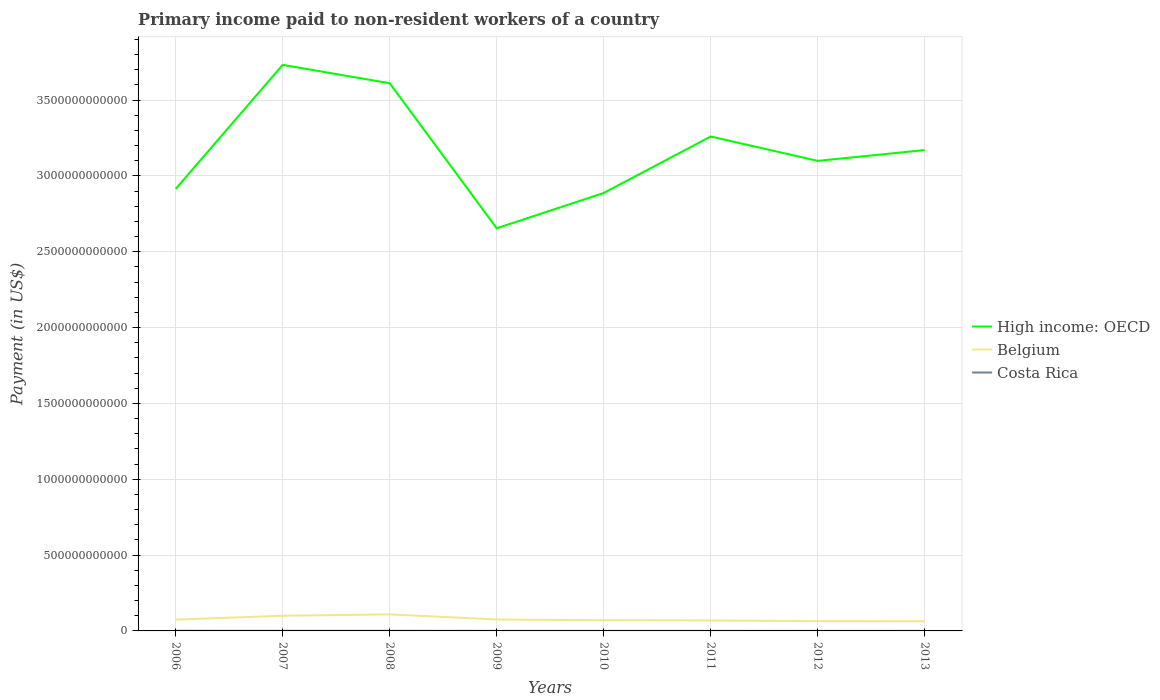How many different coloured lines are there?
Ensure brevity in your answer.  3. Does the line corresponding to High income: OECD intersect with the line corresponding to Belgium?
Your answer should be very brief. No. Across all years, what is the maximum amount paid to workers in Belgium?
Make the answer very short. 6.36e+1. In which year was the amount paid to workers in Belgium maximum?
Provide a succinct answer. 2013. What is the total amount paid to workers in Belgium in the graph?
Make the answer very short. 5.05e+09. What is the difference between the highest and the second highest amount paid to workers in Costa Rica?
Provide a short and direct response. 9.58e+08. What is the difference between the highest and the lowest amount paid to workers in High income: OECD?
Your answer should be very brief. 4. Is the amount paid to workers in High income: OECD strictly greater than the amount paid to workers in Belgium over the years?
Make the answer very short. No. What is the difference between two consecutive major ticks on the Y-axis?
Make the answer very short. 5.00e+11. Does the graph contain any zero values?
Keep it short and to the point. No. Does the graph contain grids?
Ensure brevity in your answer.  Yes. Where does the legend appear in the graph?
Offer a very short reply. Center right. How many legend labels are there?
Offer a terse response. 3. What is the title of the graph?
Make the answer very short. Primary income paid to non-resident workers of a country. Does "Moldova" appear as one of the legend labels in the graph?
Offer a very short reply. No. What is the label or title of the Y-axis?
Offer a terse response. Payment (in US$). What is the Payment (in US$) of High income: OECD in 2006?
Provide a succinct answer. 2.91e+12. What is the Payment (in US$) in Belgium in 2006?
Your answer should be very brief. 7.43e+1. What is the Payment (in US$) in Costa Rica in 2006?
Your response must be concise. 1.14e+09. What is the Payment (in US$) of High income: OECD in 2007?
Ensure brevity in your answer.  3.73e+12. What is the Payment (in US$) of Belgium in 2007?
Your answer should be compact. 1.00e+11. What is the Payment (in US$) of Costa Rica in 2007?
Keep it short and to the point. 7.08e+08. What is the Payment (in US$) of High income: OECD in 2008?
Provide a short and direct response. 3.61e+12. What is the Payment (in US$) of Belgium in 2008?
Offer a very short reply. 1.09e+11. What is the Payment (in US$) in Costa Rica in 2008?
Make the answer very short. 6.97e+08. What is the Payment (in US$) in High income: OECD in 2009?
Offer a very short reply. 2.66e+12. What is the Payment (in US$) of Belgium in 2009?
Your response must be concise. 7.54e+1. What is the Payment (in US$) in Costa Rica in 2009?
Your answer should be very brief. 1.96e+08. What is the Payment (in US$) in High income: OECD in 2010?
Give a very brief answer. 2.89e+12. What is the Payment (in US$) in Belgium in 2010?
Offer a terse response. 7.06e+1. What is the Payment (in US$) in Costa Rica in 2010?
Provide a short and direct response. 1.77e+08. What is the Payment (in US$) in High income: OECD in 2011?
Make the answer very short. 3.26e+12. What is the Payment (in US$) of Belgium in 2011?
Keep it short and to the point. 6.92e+1. What is the Payment (in US$) in Costa Rica in 2011?
Ensure brevity in your answer.  2.45e+08. What is the Payment (in US$) in High income: OECD in 2012?
Provide a succinct answer. 3.10e+12. What is the Payment (in US$) of Belgium in 2012?
Keep it short and to the point. 6.41e+1. What is the Payment (in US$) of Costa Rica in 2012?
Make the answer very short. 2.92e+08. What is the Payment (in US$) of High income: OECD in 2013?
Provide a short and direct response. 3.17e+12. What is the Payment (in US$) in Belgium in 2013?
Your response must be concise. 6.36e+1. What is the Payment (in US$) of Costa Rica in 2013?
Provide a short and direct response. 2.24e+08. Across all years, what is the maximum Payment (in US$) in High income: OECD?
Keep it short and to the point. 3.73e+12. Across all years, what is the maximum Payment (in US$) in Belgium?
Your answer should be very brief. 1.09e+11. Across all years, what is the maximum Payment (in US$) in Costa Rica?
Your answer should be very brief. 1.14e+09. Across all years, what is the minimum Payment (in US$) of High income: OECD?
Offer a very short reply. 2.66e+12. Across all years, what is the minimum Payment (in US$) in Belgium?
Offer a very short reply. 6.36e+1. Across all years, what is the minimum Payment (in US$) in Costa Rica?
Ensure brevity in your answer.  1.77e+08. What is the total Payment (in US$) in High income: OECD in the graph?
Your answer should be very brief. 2.53e+13. What is the total Payment (in US$) of Belgium in the graph?
Your response must be concise. 6.26e+11. What is the total Payment (in US$) of Costa Rica in the graph?
Make the answer very short. 3.67e+09. What is the difference between the Payment (in US$) in High income: OECD in 2006 and that in 2007?
Make the answer very short. -8.18e+11. What is the difference between the Payment (in US$) of Belgium in 2006 and that in 2007?
Your response must be concise. -2.58e+1. What is the difference between the Payment (in US$) in Costa Rica in 2006 and that in 2007?
Keep it short and to the point. 4.27e+08. What is the difference between the Payment (in US$) of High income: OECD in 2006 and that in 2008?
Provide a succinct answer. -6.97e+11. What is the difference between the Payment (in US$) of Belgium in 2006 and that in 2008?
Make the answer very short. -3.48e+1. What is the difference between the Payment (in US$) of Costa Rica in 2006 and that in 2008?
Your answer should be compact. 4.38e+08. What is the difference between the Payment (in US$) of High income: OECD in 2006 and that in 2009?
Your answer should be compact. 2.59e+11. What is the difference between the Payment (in US$) in Belgium in 2006 and that in 2009?
Provide a succinct answer. -1.16e+09. What is the difference between the Payment (in US$) in Costa Rica in 2006 and that in 2009?
Keep it short and to the point. 9.39e+08. What is the difference between the Payment (in US$) in High income: OECD in 2006 and that in 2010?
Provide a short and direct response. 2.69e+1. What is the difference between the Payment (in US$) of Belgium in 2006 and that in 2010?
Offer a very short reply. 3.67e+09. What is the difference between the Payment (in US$) of Costa Rica in 2006 and that in 2010?
Ensure brevity in your answer.  9.58e+08. What is the difference between the Payment (in US$) of High income: OECD in 2006 and that in 2011?
Ensure brevity in your answer.  -3.45e+11. What is the difference between the Payment (in US$) of Belgium in 2006 and that in 2011?
Keep it short and to the point. 5.10e+09. What is the difference between the Payment (in US$) of Costa Rica in 2006 and that in 2011?
Offer a terse response. 8.90e+08. What is the difference between the Payment (in US$) in High income: OECD in 2006 and that in 2012?
Ensure brevity in your answer.  -1.85e+11. What is the difference between the Payment (in US$) in Belgium in 2006 and that in 2012?
Your answer should be very brief. 1.02e+1. What is the difference between the Payment (in US$) in Costa Rica in 2006 and that in 2012?
Keep it short and to the point. 8.43e+08. What is the difference between the Payment (in US$) of High income: OECD in 2006 and that in 2013?
Your response must be concise. -2.56e+11. What is the difference between the Payment (in US$) in Belgium in 2006 and that in 2013?
Offer a terse response. 1.07e+1. What is the difference between the Payment (in US$) in Costa Rica in 2006 and that in 2013?
Offer a very short reply. 9.11e+08. What is the difference between the Payment (in US$) of High income: OECD in 2007 and that in 2008?
Provide a succinct answer. 1.21e+11. What is the difference between the Payment (in US$) in Belgium in 2007 and that in 2008?
Your response must be concise. -8.97e+09. What is the difference between the Payment (in US$) of Costa Rica in 2007 and that in 2008?
Offer a terse response. 1.08e+07. What is the difference between the Payment (in US$) in High income: OECD in 2007 and that in 2009?
Make the answer very short. 1.08e+12. What is the difference between the Payment (in US$) in Belgium in 2007 and that in 2009?
Give a very brief answer. 2.47e+1. What is the difference between the Payment (in US$) of Costa Rica in 2007 and that in 2009?
Keep it short and to the point. 5.11e+08. What is the difference between the Payment (in US$) in High income: OECD in 2007 and that in 2010?
Your response must be concise. 8.45e+11. What is the difference between the Payment (in US$) in Belgium in 2007 and that in 2010?
Give a very brief answer. 2.95e+1. What is the difference between the Payment (in US$) of Costa Rica in 2007 and that in 2010?
Make the answer very short. 5.31e+08. What is the difference between the Payment (in US$) in High income: OECD in 2007 and that in 2011?
Offer a terse response. 4.72e+11. What is the difference between the Payment (in US$) in Belgium in 2007 and that in 2011?
Make the answer very short. 3.09e+1. What is the difference between the Payment (in US$) in Costa Rica in 2007 and that in 2011?
Ensure brevity in your answer.  4.63e+08. What is the difference between the Payment (in US$) of High income: OECD in 2007 and that in 2012?
Provide a succinct answer. 6.33e+11. What is the difference between the Payment (in US$) in Belgium in 2007 and that in 2012?
Your answer should be very brief. 3.60e+1. What is the difference between the Payment (in US$) of Costa Rica in 2007 and that in 2012?
Ensure brevity in your answer.  4.16e+08. What is the difference between the Payment (in US$) of High income: OECD in 2007 and that in 2013?
Ensure brevity in your answer.  5.62e+11. What is the difference between the Payment (in US$) in Belgium in 2007 and that in 2013?
Offer a very short reply. 3.65e+1. What is the difference between the Payment (in US$) of Costa Rica in 2007 and that in 2013?
Keep it short and to the point. 4.83e+08. What is the difference between the Payment (in US$) in High income: OECD in 2008 and that in 2009?
Offer a very short reply. 9.56e+11. What is the difference between the Payment (in US$) in Belgium in 2008 and that in 2009?
Provide a succinct answer. 3.36e+1. What is the difference between the Payment (in US$) in Costa Rica in 2008 and that in 2009?
Give a very brief answer. 5.00e+08. What is the difference between the Payment (in US$) in High income: OECD in 2008 and that in 2010?
Make the answer very short. 7.24e+11. What is the difference between the Payment (in US$) of Belgium in 2008 and that in 2010?
Provide a succinct answer. 3.84e+1. What is the difference between the Payment (in US$) of Costa Rica in 2008 and that in 2010?
Ensure brevity in your answer.  5.20e+08. What is the difference between the Payment (in US$) of High income: OECD in 2008 and that in 2011?
Ensure brevity in your answer.  3.51e+11. What is the difference between the Payment (in US$) of Belgium in 2008 and that in 2011?
Provide a short and direct response. 3.99e+1. What is the difference between the Payment (in US$) in Costa Rica in 2008 and that in 2011?
Your answer should be compact. 4.52e+08. What is the difference between the Payment (in US$) of High income: OECD in 2008 and that in 2012?
Your response must be concise. 5.12e+11. What is the difference between the Payment (in US$) in Belgium in 2008 and that in 2012?
Ensure brevity in your answer.  4.49e+1. What is the difference between the Payment (in US$) of Costa Rica in 2008 and that in 2012?
Your answer should be very brief. 4.05e+08. What is the difference between the Payment (in US$) of High income: OECD in 2008 and that in 2013?
Offer a terse response. 4.41e+11. What is the difference between the Payment (in US$) in Belgium in 2008 and that in 2013?
Provide a short and direct response. 4.55e+1. What is the difference between the Payment (in US$) of Costa Rica in 2008 and that in 2013?
Offer a terse response. 4.72e+08. What is the difference between the Payment (in US$) in High income: OECD in 2009 and that in 2010?
Give a very brief answer. -2.33e+11. What is the difference between the Payment (in US$) of Belgium in 2009 and that in 2010?
Your answer should be compact. 4.83e+09. What is the difference between the Payment (in US$) of Costa Rica in 2009 and that in 2010?
Ensure brevity in your answer.  1.96e+07. What is the difference between the Payment (in US$) in High income: OECD in 2009 and that in 2011?
Your answer should be very brief. -6.05e+11. What is the difference between the Payment (in US$) in Belgium in 2009 and that in 2011?
Your response must be concise. 6.25e+09. What is the difference between the Payment (in US$) of Costa Rica in 2009 and that in 2011?
Provide a short and direct response. -4.87e+07. What is the difference between the Payment (in US$) in High income: OECD in 2009 and that in 2012?
Offer a very short reply. -4.44e+11. What is the difference between the Payment (in US$) in Belgium in 2009 and that in 2012?
Provide a short and direct response. 1.13e+1. What is the difference between the Payment (in US$) in Costa Rica in 2009 and that in 2012?
Offer a very short reply. -9.52e+07. What is the difference between the Payment (in US$) of High income: OECD in 2009 and that in 2013?
Keep it short and to the point. -5.16e+11. What is the difference between the Payment (in US$) in Belgium in 2009 and that in 2013?
Ensure brevity in your answer.  1.18e+1. What is the difference between the Payment (in US$) in Costa Rica in 2009 and that in 2013?
Offer a very short reply. -2.80e+07. What is the difference between the Payment (in US$) of High income: OECD in 2010 and that in 2011?
Provide a short and direct response. -3.72e+11. What is the difference between the Payment (in US$) in Belgium in 2010 and that in 2011?
Keep it short and to the point. 1.43e+09. What is the difference between the Payment (in US$) of Costa Rica in 2010 and that in 2011?
Ensure brevity in your answer.  -6.83e+07. What is the difference between the Payment (in US$) of High income: OECD in 2010 and that in 2012?
Offer a terse response. -2.12e+11. What is the difference between the Payment (in US$) in Belgium in 2010 and that in 2012?
Provide a short and direct response. 6.48e+09. What is the difference between the Payment (in US$) in Costa Rica in 2010 and that in 2012?
Your answer should be compact. -1.15e+08. What is the difference between the Payment (in US$) of High income: OECD in 2010 and that in 2013?
Provide a succinct answer. -2.83e+11. What is the difference between the Payment (in US$) of Belgium in 2010 and that in 2013?
Give a very brief answer. 7.02e+09. What is the difference between the Payment (in US$) in Costa Rica in 2010 and that in 2013?
Provide a short and direct response. -4.76e+07. What is the difference between the Payment (in US$) in High income: OECD in 2011 and that in 2012?
Provide a short and direct response. 1.61e+11. What is the difference between the Payment (in US$) in Belgium in 2011 and that in 2012?
Offer a very short reply. 5.05e+09. What is the difference between the Payment (in US$) in Costa Rica in 2011 and that in 2012?
Give a very brief answer. -4.65e+07. What is the difference between the Payment (in US$) in High income: OECD in 2011 and that in 2013?
Provide a short and direct response. 8.92e+1. What is the difference between the Payment (in US$) of Belgium in 2011 and that in 2013?
Your answer should be very brief. 5.59e+09. What is the difference between the Payment (in US$) in Costa Rica in 2011 and that in 2013?
Provide a short and direct response. 2.07e+07. What is the difference between the Payment (in US$) of High income: OECD in 2012 and that in 2013?
Provide a short and direct response. -7.13e+1. What is the difference between the Payment (in US$) of Belgium in 2012 and that in 2013?
Offer a very short reply. 5.38e+08. What is the difference between the Payment (in US$) of Costa Rica in 2012 and that in 2013?
Your response must be concise. 6.72e+07. What is the difference between the Payment (in US$) in High income: OECD in 2006 and the Payment (in US$) in Belgium in 2007?
Keep it short and to the point. 2.81e+12. What is the difference between the Payment (in US$) of High income: OECD in 2006 and the Payment (in US$) of Costa Rica in 2007?
Your answer should be very brief. 2.91e+12. What is the difference between the Payment (in US$) of Belgium in 2006 and the Payment (in US$) of Costa Rica in 2007?
Keep it short and to the point. 7.36e+1. What is the difference between the Payment (in US$) of High income: OECD in 2006 and the Payment (in US$) of Belgium in 2008?
Provide a short and direct response. 2.81e+12. What is the difference between the Payment (in US$) in High income: OECD in 2006 and the Payment (in US$) in Costa Rica in 2008?
Your answer should be very brief. 2.91e+12. What is the difference between the Payment (in US$) in Belgium in 2006 and the Payment (in US$) in Costa Rica in 2008?
Offer a very short reply. 7.36e+1. What is the difference between the Payment (in US$) in High income: OECD in 2006 and the Payment (in US$) in Belgium in 2009?
Keep it short and to the point. 2.84e+12. What is the difference between the Payment (in US$) of High income: OECD in 2006 and the Payment (in US$) of Costa Rica in 2009?
Make the answer very short. 2.91e+12. What is the difference between the Payment (in US$) in Belgium in 2006 and the Payment (in US$) in Costa Rica in 2009?
Offer a very short reply. 7.41e+1. What is the difference between the Payment (in US$) of High income: OECD in 2006 and the Payment (in US$) of Belgium in 2010?
Provide a short and direct response. 2.84e+12. What is the difference between the Payment (in US$) in High income: OECD in 2006 and the Payment (in US$) in Costa Rica in 2010?
Make the answer very short. 2.91e+12. What is the difference between the Payment (in US$) of Belgium in 2006 and the Payment (in US$) of Costa Rica in 2010?
Offer a very short reply. 7.41e+1. What is the difference between the Payment (in US$) in High income: OECD in 2006 and the Payment (in US$) in Belgium in 2011?
Ensure brevity in your answer.  2.85e+12. What is the difference between the Payment (in US$) of High income: OECD in 2006 and the Payment (in US$) of Costa Rica in 2011?
Make the answer very short. 2.91e+12. What is the difference between the Payment (in US$) of Belgium in 2006 and the Payment (in US$) of Costa Rica in 2011?
Give a very brief answer. 7.40e+1. What is the difference between the Payment (in US$) of High income: OECD in 2006 and the Payment (in US$) of Belgium in 2012?
Ensure brevity in your answer.  2.85e+12. What is the difference between the Payment (in US$) in High income: OECD in 2006 and the Payment (in US$) in Costa Rica in 2012?
Provide a short and direct response. 2.91e+12. What is the difference between the Payment (in US$) in Belgium in 2006 and the Payment (in US$) in Costa Rica in 2012?
Offer a terse response. 7.40e+1. What is the difference between the Payment (in US$) in High income: OECD in 2006 and the Payment (in US$) in Belgium in 2013?
Offer a very short reply. 2.85e+12. What is the difference between the Payment (in US$) of High income: OECD in 2006 and the Payment (in US$) of Costa Rica in 2013?
Offer a terse response. 2.91e+12. What is the difference between the Payment (in US$) of Belgium in 2006 and the Payment (in US$) of Costa Rica in 2013?
Your answer should be compact. 7.41e+1. What is the difference between the Payment (in US$) of High income: OECD in 2007 and the Payment (in US$) of Belgium in 2008?
Ensure brevity in your answer.  3.62e+12. What is the difference between the Payment (in US$) of High income: OECD in 2007 and the Payment (in US$) of Costa Rica in 2008?
Make the answer very short. 3.73e+12. What is the difference between the Payment (in US$) of Belgium in 2007 and the Payment (in US$) of Costa Rica in 2008?
Your answer should be compact. 9.94e+1. What is the difference between the Payment (in US$) in High income: OECD in 2007 and the Payment (in US$) in Belgium in 2009?
Offer a very short reply. 3.66e+12. What is the difference between the Payment (in US$) in High income: OECD in 2007 and the Payment (in US$) in Costa Rica in 2009?
Keep it short and to the point. 3.73e+12. What is the difference between the Payment (in US$) in Belgium in 2007 and the Payment (in US$) in Costa Rica in 2009?
Your answer should be very brief. 9.99e+1. What is the difference between the Payment (in US$) in High income: OECD in 2007 and the Payment (in US$) in Belgium in 2010?
Offer a terse response. 3.66e+12. What is the difference between the Payment (in US$) of High income: OECD in 2007 and the Payment (in US$) of Costa Rica in 2010?
Keep it short and to the point. 3.73e+12. What is the difference between the Payment (in US$) in Belgium in 2007 and the Payment (in US$) in Costa Rica in 2010?
Provide a short and direct response. 9.99e+1. What is the difference between the Payment (in US$) in High income: OECD in 2007 and the Payment (in US$) in Belgium in 2011?
Offer a terse response. 3.66e+12. What is the difference between the Payment (in US$) in High income: OECD in 2007 and the Payment (in US$) in Costa Rica in 2011?
Your answer should be very brief. 3.73e+12. What is the difference between the Payment (in US$) of Belgium in 2007 and the Payment (in US$) of Costa Rica in 2011?
Provide a succinct answer. 9.98e+1. What is the difference between the Payment (in US$) in High income: OECD in 2007 and the Payment (in US$) in Belgium in 2012?
Make the answer very short. 3.67e+12. What is the difference between the Payment (in US$) in High income: OECD in 2007 and the Payment (in US$) in Costa Rica in 2012?
Your answer should be compact. 3.73e+12. What is the difference between the Payment (in US$) in Belgium in 2007 and the Payment (in US$) in Costa Rica in 2012?
Provide a succinct answer. 9.98e+1. What is the difference between the Payment (in US$) in High income: OECD in 2007 and the Payment (in US$) in Belgium in 2013?
Keep it short and to the point. 3.67e+12. What is the difference between the Payment (in US$) of High income: OECD in 2007 and the Payment (in US$) of Costa Rica in 2013?
Keep it short and to the point. 3.73e+12. What is the difference between the Payment (in US$) of Belgium in 2007 and the Payment (in US$) of Costa Rica in 2013?
Ensure brevity in your answer.  9.99e+1. What is the difference between the Payment (in US$) of High income: OECD in 2008 and the Payment (in US$) of Belgium in 2009?
Provide a short and direct response. 3.54e+12. What is the difference between the Payment (in US$) in High income: OECD in 2008 and the Payment (in US$) in Costa Rica in 2009?
Keep it short and to the point. 3.61e+12. What is the difference between the Payment (in US$) of Belgium in 2008 and the Payment (in US$) of Costa Rica in 2009?
Make the answer very short. 1.09e+11. What is the difference between the Payment (in US$) of High income: OECD in 2008 and the Payment (in US$) of Belgium in 2010?
Your response must be concise. 3.54e+12. What is the difference between the Payment (in US$) of High income: OECD in 2008 and the Payment (in US$) of Costa Rica in 2010?
Give a very brief answer. 3.61e+12. What is the difference between the Payment (in US$) in Belgium in 2008 and the Payment (in US$) in Costa Rica in 2010?
Provide a succinct answer. 1.09e+11. What is the difference between the Payment (in US$) of High income: OECD in 2008 and the Payment (in US$) of Belgium in 2011?
Offer a terse response. 3.54e+12. What is the difference between the Payment (in US$) of High income: OECD in 2008 and the Payment (in US$) of Costa Rica in 2011?
Provide a short and direct response. 3.61e+12. What is the difference between the Payment (in US$) of Belgium in 2008 and the Payment (in US$) of Costa Rica in 2011?
Make the answer very short. 1.09e+11. What is the difference between the Payment (in US$) in High income: OECD in 2008 and the Payment (in US$) in Belgium in 2012?
Your answer should be compact. 3.55e+12. What is the difference between the Payment (in US$) of High income: OECD in 2008 and the Payment (in US$) of Costa Rica in 2012?
Ensure brevity in your answer.  3.61e+12. What is the difference between the Payment (in US$) of Belgium in 2008 and the Payment (in US$) of Costa Rica in 2012?
Provide a succinct answer. 1.09e+11. What is the difference between the Payment (in US$) in High income: OECD in 2008 and the Payment (in US$) in Belgium in 2013?
Offer a terse response. 3.55e+12. What is the difference between the Payment (in US$) in High income: OECD in 2008 and the Payment (in US$) in Costa Rica in 2013?
Keep it short and to the point. 3.61e+12. What is the difference between the Payment (in US$) in Belgium in 2008 and the Payment (in US$) in Costa Rica in 2013?
Offer a terse response. 1.09e+11. What is the difference between the Payment (in US$) in High income: OECD in 2009 and the Payment (in US$) in Belgium in 2010?
Offer a terse response. 2.58e+12. What is the difference between the Payment (in US$) in High income: OECD in 2009 and the Payment (in US$) in Costa Rica in 2010?
Provide a short and direct response. 2.66e+12. What is the difference between the Payment (in US$) in Belgium in 2009 and the Payment (in US$) in Costa Rica in 2010?
Make the answer very short. 7.53e+1. What is the difference between the Payment (in US$) in High income: OECD in 2009 and the Payment (in US$) in Belgium in 2011?
Your answer should be compact. 2.59e+12. What is the difference between the Payment (in US$) of High income: OECD in 2009 and the Payment (in US$) of Costa Rica in 2011?
Make the answer very short. 2.65e+12. What is the difference between the Payment (in US$) in Belgium in 2009 and the Payment (in US$) in Costa Rica in 2011?
Provide a short and direct response. 7.52e+1. What is the difference between the Payment (in US$) in High income: OECD in 2009 and the Payment (in US$) in Belgium in 2012?
Provide a succinct answer. 2.59e+12. What is the difference between the Payment (in US$) of High income: OECD in 2009 and the Payment (in US$) of Costa Rica in 2012?
Your answer should be compact. 2.65e+12. What is the difference between the Payment (in US$) of Belgium in 2009 and the Payment (in US$) of Costa Rica in 2012?
Make the answer very short. 7.51e+1. What is the difference between the Payment (in US$) in High income: OECD in 2009 and the Payment (in US$) in Belgium in 2013?
Your answer should be compact. 2.59e+12. What is the difference between the Payment (in US$) in High income: OECD in 2009 and the Payment (in US$) in Costa Rica in 2013?
Provide a short and direct response. 2.65e+12. What is the difference between the Payment (in US$) in Belgium in 2009 and the Payment (in US$) in Costa Rica in 2013?
Your response must be concise. 7.52e+1. What is the difference between the Payment (in US$) of High income: OECD in 2010 and the Payment (in US$) of Belgium in 2011?
Provide a short and direct response. 2.82e+12. What is the difference between the Payment (in US$) in High income: OECD in 2010 and the Payment (in US$) in Costa Rica in 2011?
Provide a short and direct response. 2.89e+12. What is the difference between the Payment (in US$) of Belgium in 2010 and the Payment (in US$) of Costa Rica in 2011?
Make the answer very short. 7.04e+1. What is the difference between the Payment (in US$) in High income: OECD in 2010 and the Payment (in US$) in Belgium in 2012?
Provide a succinct answer. 2.82e+12. What is the difference between the Payment (in US$) in High income: OECD in 2010 and the Payment (in US$) in Costa Rica in 2012?
Make the answer very short. 2.89e+12. What is the difference between the Payment (in US$) of Belgium in 2010 and the Payment (in US$) of Costa Rica in 2012?
Offer a very short reply. 7.03e+1. What is the difference between the Payment (in US$) of High income: OECD in 2010 and the Payment (in US$) of Belgium in 2013?
Your answer should be very brief. 2.82e+12. What is the difference between the Payment (in US$) of High income: OECD in 2010 and the Payment (in US$) of Costa Rica in 2013?
Your answer should be compact. 2.89e+12. What is the difference between the Payment (in US$) in Belgium in 2010 and the Payment (in US$) in Costa Rica in 2013?
Provide a succinct answer. 7.04e+1. What is the difference between the Payment (in US$) in High income: OECD in 2011 and the Payment (in US$) in Belgium in 2012?
Provide a short and direct response. 3.20e+12. What is the difference between the Payment (in US$) in High income: OECD in 2011 and the Payment (in US$) in Costa Rica in 2012?
Your answer should be compact. 3.26e+12. What is the difference between the Payment (in US$) of Belgium in 2011 and the Payment (in US$) of Costa Rica in 2012?
Your answer should be very brief. 6.89e+1. What is the difference between the Payment (in US$) of High income: OECD in 2011 and the Payment (in US$) of Belgium in 2013?
Your answer should be very brief. 3.20e+12. What is the difference between the Payment (in US$) of High income: OECD in 2011 and the Payment (in US$) of Costa Rica in 2013?
Make the answer very short. 3.26e+12. What is the difference between the Payment (in US$) of Belgium in 2011 and the Payment (in US$) of Costa Rica in 2013?
Keep it short and to the point. 6.90e+1. What is the difference between the Payment (in US$) of High income: OECD in 2012 and the Payment (in US$) of Belgium in 2013?
Offer a terse response. 3.04e+12. What is the difference between the Payment (in US$) in High income: OECD in 2012 and the Payment (in US$) in Costa Rica in 2013?
Your answer should be compact. 3.10e+12. What is the difference between the Payment (in US$) of Belgium in 2012 and the Payment (in US$) of Costa Rica in 2013?
Your answer should be compact. 6.39e+1. What is the average Payment (in US$) in High income: OECD per year?
Your response must be concise. 3.17e+12. What is the average Payment (in US$) of Belgium per year?
Ensure brevity in your answer.  7.83e+1. What is the average Payment (in US$) in Costa Rica per year?
Your answer should be compact. 4.59e+08. In the year 2006, what is the difference between the Payment (in US$) of High income: OECD and Payment (in US$) of Belgium?
Provide a short and direct response. 2.84e+12. In the year 2006, what is the difference between the Payment (in US$) in High income: OECD and Payment (in US$) in Costa Rica?
Your answer should be compact. 2.91e+12. In the year 2006, what is the difference between the Payment (in US$) of Belgium and Payment (in US$) of Costa Rica?
Your answer should be compact. 7.31e+1. In the year 2007, what is the difference between the Payment (in US$) in High income: OECD and Payment (in US$) in Belgium?
Your response must be concise. 3.63e+12. In the year 2007, what is the difference between the Payment (in US$) of High income: OECD and Payment (in US$) of Costa Rica?
Your answer should be compact. 3.73e+12. In the year 2007, what is the difference between the Payment (in US$) in Belgium and Payment (in US$) in Costa Rica?
Your answer should be compact. 9.94e+1. In the year 2008, what is the difference between the Payment (in US$) of High income: OECD and Payment (in US$) of Belgium?
Keep it short and to the point. 3.50e+12. In the year 2008, what is the difference between the Payment (in US$) of High income: OECD and Payment (in US$) of Costa Rica?
Keep it short and to the point. 3.61e+12. In the year 2008, what is the difference between the Payment (in US$) of Belgium and Payment (in US$) of Costa Rica?
Give a very brief answer. 1.08e+11. In the year 2009, what is the difference between the Payment (in US$) of High income: OECD and Payment (in US$) of Belgium?
Provide a short and direct response. 2.58e+12. In the year 2009, what is the difference between the Payment (in US$) in High income: OECD and Payment (in US$) in Costa Rica?
Provide a short and direct response. 2.65e+12. In the year 2009, what is the difference between the Payment (in US$) in Belgium and Payment (in US$) in Costa Rica?
Ensure brevity in your answer.  7.52e+1. In the year 2010, what is the difference between the Payment (in US$) of High income: OECD and Payment (in US$) of Belgium?
Provide a succinct answer. 2.82e+12. In the year 2010, what is the difference between the Payment (in US$) of High income: OECD and Payment (in US$) of Costa Rica?
Offer a terse response. 2.89e+12. In the year 2010, what is the difference between the Payment (in US$) in Belgium and Payment (in US$) in Costa Rica?
Keep it short and to the point. 7.04e+1. In the year 2011, what is the difference between the Payment (in US$) of High income: OECD and Payment (in US$) of Belgium?
Keep it short and to the point. 3.19e+12. In the year 2011, what is the difference between the Payment (in US$) in High income: OECD and Payment (in US$) in Costa Rica?
Ensure brevity in your answer.  3.26e+12. In the year 2011, what is the difference between the Payment (in US$) of Belgium and Payment (in US$) of Costa Rica?
Offer a very short reply. 6.89e+1. In the year 2012, what is the difference between the Payment (in US$) in High income: OECD and Payment (in US$) in Belgium?
Provide a succinct answer. 3.04e+12. In the year 2012, what is the difference between the Payment (in US$) in High income: OECD and Payment (in US$) in Costa Rica?
Offer a terse response. 3.10e+12. In the year 2012, what is the difference between the Payment (in US$) of Belgium and Payment (in US$) of Costa Rica?
Give a very brief answer. 6.38e+1. In the year 2013, what is the difference between the Payment (in US$) in High income: OECD and Payment (in US$) in Belgium?
Give a very brief answer. 3.11e+12. In the year 2013, what is the difference between the Payment (in US$) in High income: OECD and Payment (in US$) in Costa Rica?
Your answer should be compact. 3.17e+12. In the year 2013, what is the difference between the Payment (in US$) in Belgium and Payment (in US$) in Costa Rica?
Your response must be concise. 6.34e+1. What is the ratio of the Payment (in US$) of High income: OECD in 2006 to that in 2007?
Your answer should be compact. 0.78. What is the ratio of the Payment (in US$) of Belgium in 2006 to that in 2007?
Your response must be concise. 0.74. What is the ratio of the Payment (in US$) in Costa Rica in 2006 to that in 2007?
Your response must be concise. 1.6. What is the ratio of the Payment (in US$) of High income: OECD in 2006 to that in 2008?
Give a very brief answer. 0.81. What is the ratio of the Payment (in US$) in Belgium in 2006 to that in 2008?
Ensure brevity in your answer.  0.68. What is the ratio of the Payment (in US$) of Costa Rica in 2006 to that in 2008?
Your answer should be compact. 1.63. What is the ratio of the Payment (in US$) of High income: OECD in 2006 to that in 2009?
Offer a terse response. 1.1. What is the ratio of the Payment (in US$) in Belgium in 2006 to that in 2009?
Provide a succinct answer. 0.98. What is the ratio of the Payment (in US$) of Costa Rica in 2006 to that in 2009?
Your answer should be very brief. 5.78. What is the ratio of the Payment (in US$) in High income: OECD in 2006 to that in 2010?
Make the answer very short. 1.01. What is the ratio of the Payment (in US$) in Belgium in 2006 to that in 2010?
Your answer should be very brief. 1.05. What is the ratio of the Payment (in US$) of Costa Rica in 2006 to that in 2010?
Ensure brevity in your answer.  6.42. What is the ratio of the Payment (in US$) of High income: OECD in 2006 to that in 2011?
Your response must be concise. 0.89. What is the ratio of the Payment (in US$) in Belgium in 2006 to that in 2011?
Ensure brevity in your answer.  1.07. What is the ratio of the Payment (in US$) of Costa Rica in 2006 to that in 2011?
Ensure brevity in your answer.  4.63. What is the ratio of the Payment (in US$) of High income: OECD in 2006 to that in 2012?
Offer a terse response. 0.94. What is the ratio of the Payment (in US$) of Belgium in 2006 to that in 2012?
Offer a very short reply. 1.16. What is the ratio of the Payment (in US$) in Costa Rica in 2006 to that in 2012?
Keep it short and to the point. 3.89. What is the ratio of the Payment (in US$) of High income: OECD in 2006 to that in 2013?
Your answer should be compact. 0.92. What is the ratio of the Payment (in US$) of Belgium in 2006 to that in 2013?
Provide a short and direct response. 1.17. What is the ratio of the Payment (in US$) in Costa Rica in 2006 to that in 2013?
Offer a terse response. 5.06. What is the ratio of the Payment (in US$) in High income: OECD in 2007 to that in 2008?
Your response must be concise. 1.03. What is the ratio of the Payment (in US$) in Belgium in 2007 to that in 2008?
Provide a succinct answer. 0.92. What is the ratio of the Payment (in US$) in Costa Rica in 2007 to that in 2008?
Give a very brief answer. 1.02. What is the ratio of the Payment (in US$) in High income: OECD in 2007 to that in 2009?
Give a very brief answer. 1.41. What is the ratio of the Payment (in US$) of Belgium in 2007 to that in 2009?
Keep it short and to the point. 1.33. What is the ratio of the Payment (in US$) of Costa Rica in 2007 to that in 2009?
Your answer should be very brief. 3.6. What is the ratio of the Payment (in US$) in High income: OECD in 2007 to that in 2010?
Ensure brevity in your answer.  1.29. What is the ratio of the Payment (in US$) of Belgium in 2007 to that in 2010?
Keep it short and to the point. 1.42. What is the ratio of the Payment (in US$) in Costa Rica in 2007 to that in 2010?
Make the answer very short. 4. What is the ratio of the Payment (in US$) in High income: OECD in 2007 to that in 2011?
Your answer should be compact. 1.14. What is the ratio of the Payment (in US$) of Belgium in 2007 to that in 2011?
Offer a very short reply. 1.45. What is the ratio of the Payment (in US$) of Costa Rica in 2007 to that in 2011?
Offer a very short reply. 2.89. What is the ratio of the Payment (in US$) of High income: OECD in 2007 to that in 2012?
Your answer should be compact. 1.2. What is the ratio of the Payment (in US$) in Belgium in 2007 to that in 2012?
Make the answer very short. 1.56. What is the ratio of the Payment (in US$) of Costa Rica in 2007 to that in 2012?
Offer a terse response. 2.43. What is the ratio of the Payment (in US$) in High income: OECD in 2007 to that in 2013?
Provide a succinct answer. 1.18. What is the ratio of the Payment (in US$) in Belgium in 2007 to that in 2013?
Provide a short and direct response. 1.57. What is the ratio of the Payment (in US$) in Costa Rica in 2007 to that in 2013?
Keep it short and to the point. 3.15. What is the ratio of the Payment (in US$) in High income: OECD in 2008 to that in 2009?
Your answer should be compact. 1.36. What is the ratio of the Payment (in US$) of Belgium in 2008 to that in 2009?
Keep it short and to the point. 1.45. What is the ratio of the Payment (in US$) in Costa Rica in 2008 to that in 2009?
Your answer should be compact. 3.55. What is the ratio of the Payment (in US$) of High income: OECD in 2008 to that in 2010?
Ensure brevity in your answer.  1.25. What is the ratio of the Payment (in US$) of Belgium in 2008 to that in 2010?
Make the answer very short. 1.54. What is the ratio of the Payment (in US$) of Costa Rica in 2008 to that in 2010?
Offer a very short reply. 3.94. What is the ratio of the Payment (in US$) in High income: OECD in 2008 to that in 2011?
Provide a short and direct response. 1.11. What is the ratio of the Payment (in US$) in Belgium in 2008 to that in 2011?
Ensure brevity in your answer.  1.58. What is the ratio of the Payment (in US$) of Costa Rica in 2008 to that in 2011?
Give a very brief answer. 2.84. What is the ratio of the Payment (in US$) in High income: OECD in 2008 to that in 2012?
Keep it short and to the point. 1.17. What is the ratio of the Payment (in US$) of Belgium in 2008 to that in 2012?
Your response must be concise. 1.7. What is the ratio of the Payment (in US$) in Costa Rica in 2008 to that in 2012?
Ensure brevity in your answer.  2.39. What is the ratio of the Payment (in US$) of High income: OECD in 2008 to that in 2013?
Your answer should be very brief. 1.14. What is the ratio of the Payment (in US$) in Belgium in 2008 to that in 2013?
Provide a succinct answer. 1.72. What is the ratio of the Payment (in US$) of Costa Rica in 2008 to that in 2013?
Give a very brief answer. 3.1. What is the ratio of the Payment (in US$) of High income: OECD in 2009 to that in 2010?
Give a very brief answer. 0.92. What is the ratio of the Payment (in US$) in Belgium in 2009 to that in 2010?
Your answer should be very brief. 1.07. What is the ratio of the Payment (in US$) in Costa Rica in 2009 to that in 2010?
Provide a succinct answer. 1.11. What is the ratio of the Payment (in US$) of High income: OECD in 2009 to that in 2011?
Offer a very short reply. 0.81. What is the ratio of the Payment (in US$) of Belgium in 2009 to that in 2011?
Keep it short and to the point. 1.09. What is the ratio of the Payment (in US$) in Costa Rica in 2009 to that in 2011?
Provide a succinct answer. 0.8. What is the ratio of the Payment (in US$) of High income: OECD in 2009 to that in 2012?
Keep it short and to the point. 0.86. What is the ratio of the Payment (in US$) in Belgium in 2009 to that in 2012?
Offer a terse response. 1.18. What is the ratio of the Payment (in US$) of Costa Rica in 2009 to that in 2012?
Offer a very short reply. 0.67. What is the ratio of the Payment (in US$) of High income: OECD in 2009 to that in 2013?
Your answer should be very brief. 0.84. What is the ratio of the Payment (in US$) of Belgium in 2009 to that in 2013?
Provide a short and direct response. 1.19. What is the ratio of the Payment (in US$) of Costa Rica in 2009 to that in 2013?
Give a very brief answer. 0.88. What is the ratio of the Payment (in US$) in High income: OECD in 2010 to that in 2011?
Provide a short and direct response. 0.89. What is the ratio of the Payment (in US$) of Belgium in 2010 to that in 2011?
Make the answer very short. 1.02. What is the ratio of the Payment (in US$) of Costa Rica in 2010 to that in 2011?
Your answer should be compact. 0.72. What is the ratio of the Payment (in US$) in High income: OECD in 2010 to that in 2012?
Provide a short and direct response. 0.93. What is the ratio of the Payment (in US$) of Belgium in 2010 to that in 2012?
Ensure brevity in your answer.  1.1. What is the ratio of the Payment (in US$) of Costa Rica in 2010 to that in 2012?
Make the answer very short. 0.61. What is the ratio of the Payment (in US$) in High income: OECD in 2010 to that in 2013?
Your answer should be compact. 0.91. What is the ratio of the Payment (in US$) of Belgium in 2010 to that in 2013?
Provide a succinct answer. 1.11. What is the ratio of the Payment (in US$) of Costa Rica in 2010 to that in 2013?
Provide a short and direct response. 0.79. What is the ratio of the Payment (in US$) in High income: OECD in 2011 to that in 2012?
Ensure brevity in your answer.  1.05. What is the ratio of the Payment (in US$) in Belgium in 2011 to that in 2012?
Provide a short and direct response. 1.08. What is the ratio of the Payment (in US$) of Costa Rica in 2011 to that in 2012?
Offer a very short reply. 0.84. What is the ratio of the Payment (in US$) in High income: OECD in 2011 to that in 2013?
Make the answer very short. 1.03. What is the ratio of the Payment (in US$) of Belgium in 2011 to that in 2013?
Offer a terse response. 1.09. What is the ratio of the Payment (in US$) of Costa Rica in 2011 to that in 2013?
Provide a succinct answer. 1.09. What is the ratio of the Payment (in US$) of High income: OECD in 2012 to that in 2013?
Offer a terse response. 0.98. What is the ratio of the Payment (in US$) in Belgium in 2012 to that in 2013?
Ensure brevity in your answer.  1.01. What is the ratio of the Payment (in US$) of Costa Rica in 2012 to that in 2013?
Make the answer very short. 1.3. What is the difference between the highest and the second highest Payment (in US$) of High income: OECD?
Your answer should be very brief. 1.21e+11. What is the difference between the highest and the second highest Payment (in US$) in Belgium?
Your answer should be compact. 8.97e+09. What is the difference between the highest and the second highest Payment (in US$) of Costa Rica?
Give a very brief answer. 4.27e+08. What is the difference between the highest and the lowest Payment (in US$) of High income: OECD?
Make the answer very short. 1.08e+12. What is the difference between the highest and the lowest Payment (in US$) of Belgium?
Offer a very short reply. 4.55e+1. What is the difference between the highest and the lowest Payment (in US$) of Costa Rica?
Offer a terse response. 9.58e+08. 